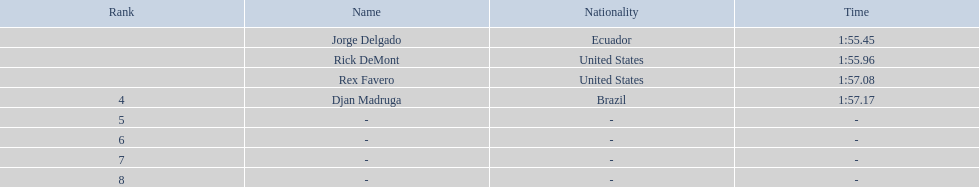After favero's finish at 1:5 1:57.17. 